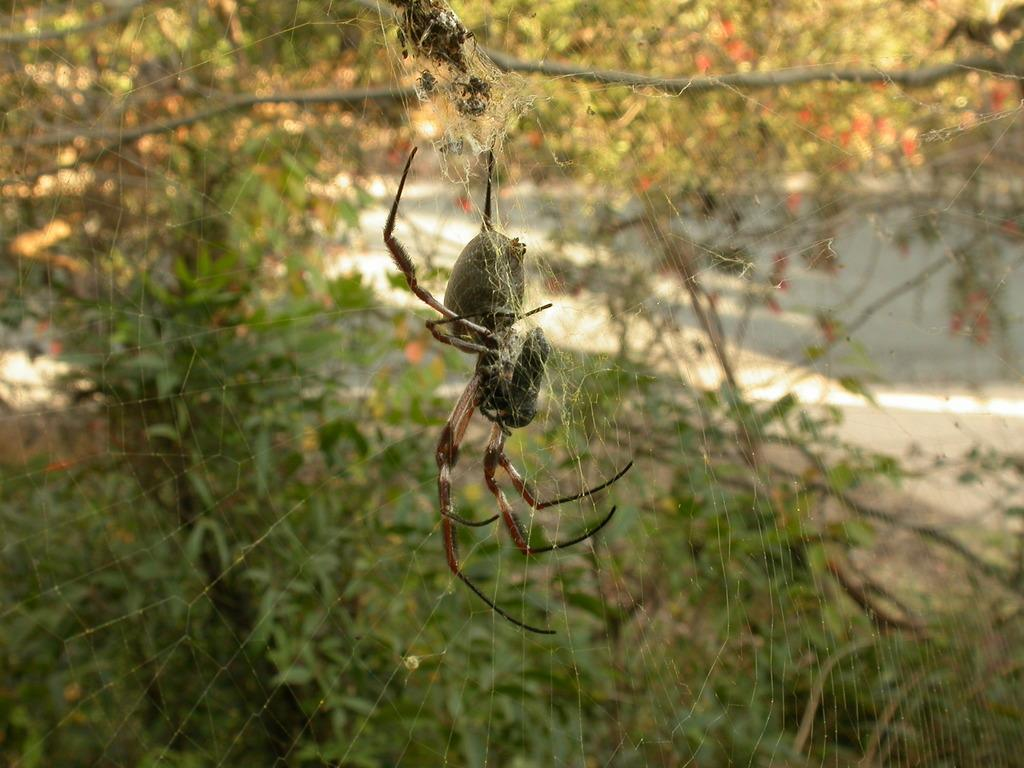What is present on the web in the image? There is a spider on the web. What can be seen in the background of the image? There are trees and plants in the background. What type of surface is visible in the image? There is ground visible in the image. How many dogs are present in the image? There are no dogs present in the image. What type of headwear is the spider wearing in the image? The spider does not have any headwear, as it is a spider and not a person. 